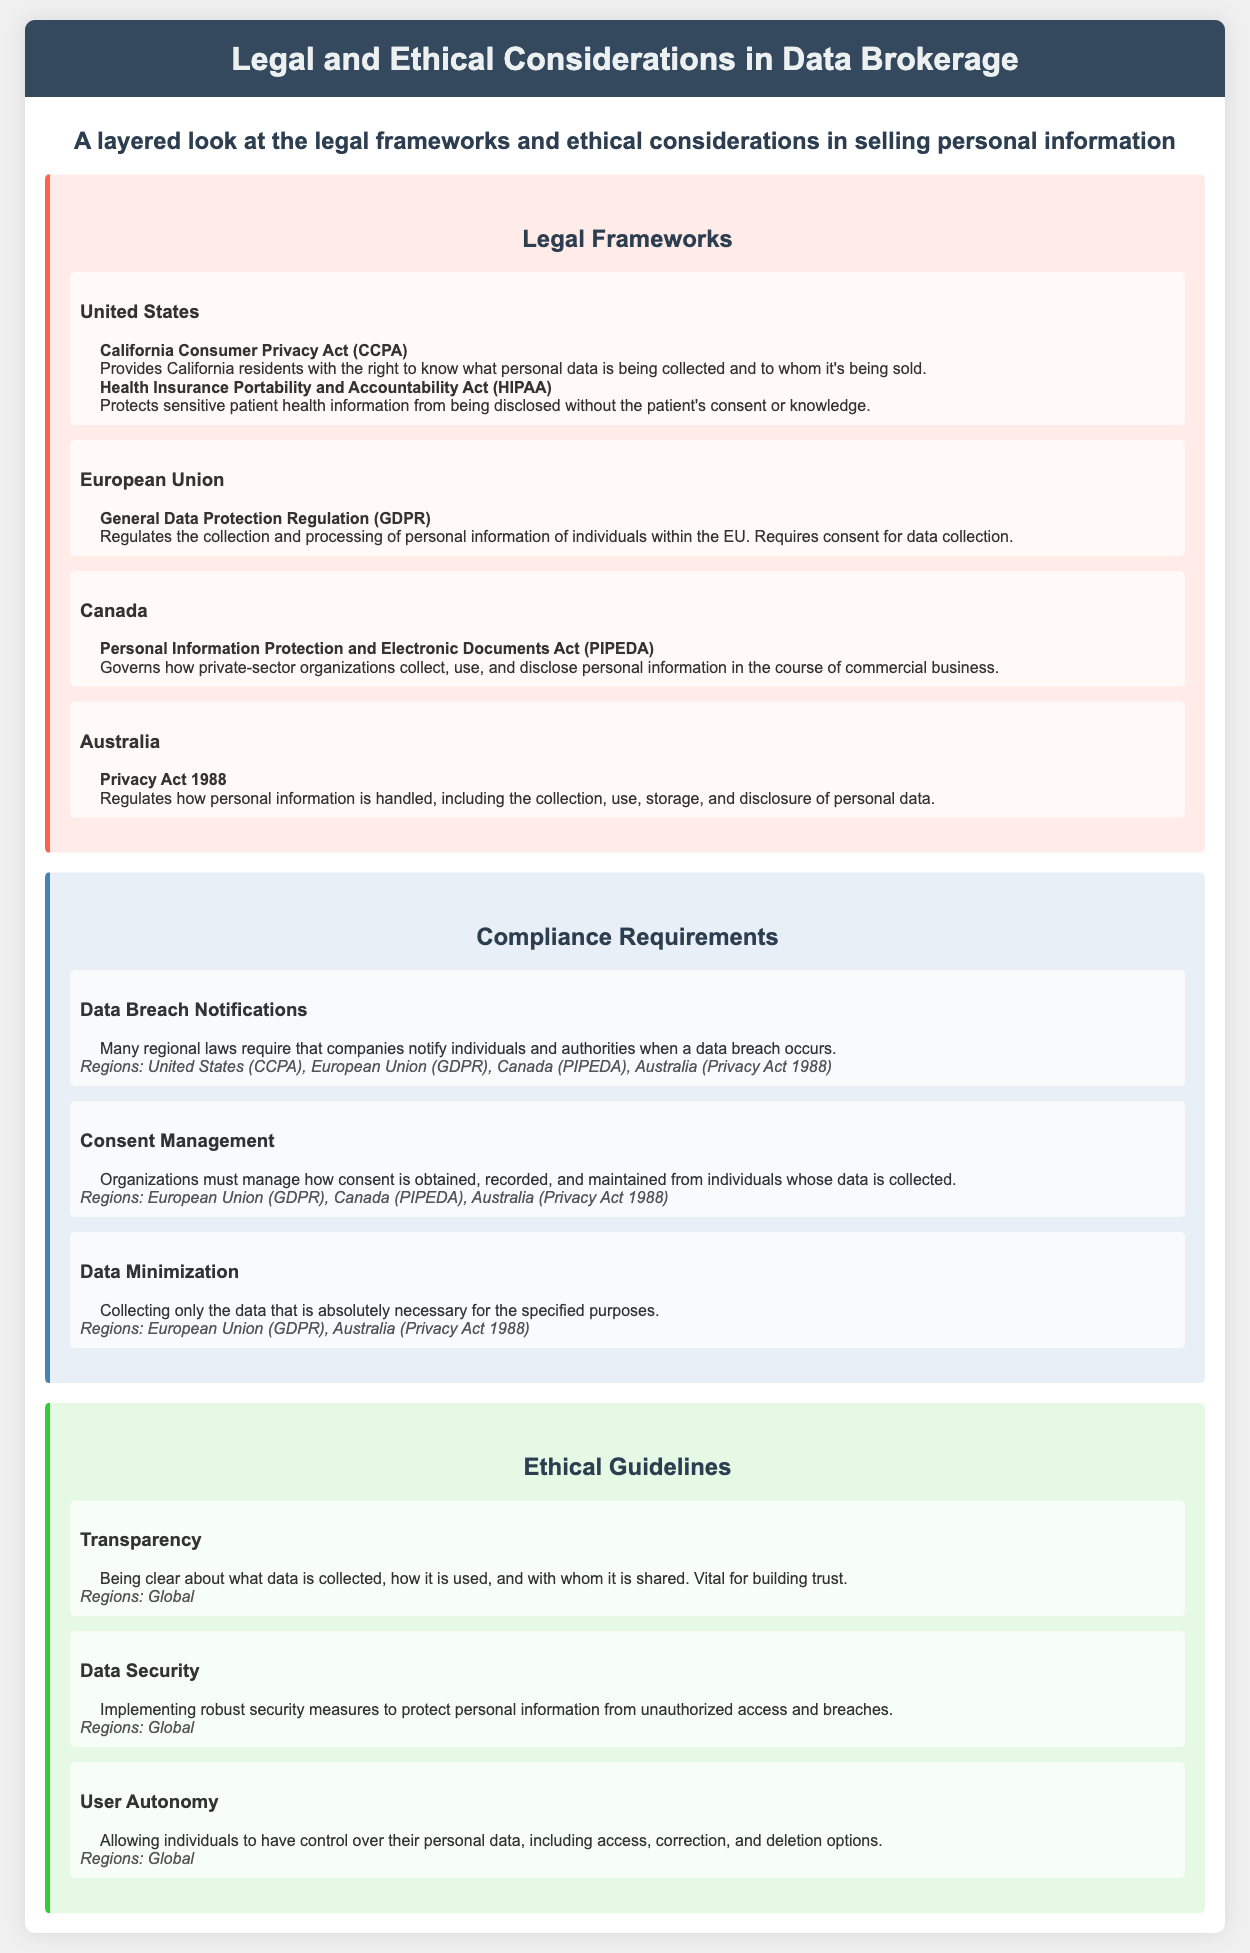What is the legal framework mentioned for California? The document states that the California Consumer Privacy Act (CCPA) is a legal framework mentioned for California.
Answer: California Consumer Privacy Act (CCPA) Which law protects patient health information in the U.S.? The document specifies that the Health Insurance Portability and Accountability Act (HIPAA) protects patient health information in the U.S.
Answer: Health Insurance Portability and Accountability Act (HIPAA) What is the main requirement of GDPR regarding data collection? The description in the document indicates that GDPR requires consent for data collection.
Answer: Consent Which compliance requirement involves notifying about data breaches? The document highlights that Data Breach Notifications is a compliance requirement necessitating notification after a breach.
Answer: Data Breach Notifications What ethical guideline emphasizes clarity about data usage? Transparency is identified in the document as the ethical guideline emphasizing clarity about data usage.
Answer: Transparency Which region's law governs how private-sector organizations collect personal information? The document notes that Canada's Personal Information Protection and Electronic Documents Act (PIPEDA) governs this aspect.
Answer: Canada How many compliance requirements are mentioned in total? The document lists three compliance requirements: Data Breach Notifications, Consent Management, and Data Minimization.
Answer: Three What is a common ethical guideline applicable globally? The document mentions that Data Security is a common ethical guideline applicable globally.
Answer: Data Security Which law in Australia regulates personal information handling? The document states that the Privacy Act 1988 regulates the handling of personal information in Australia.
Answer: Privacy Act 1988 